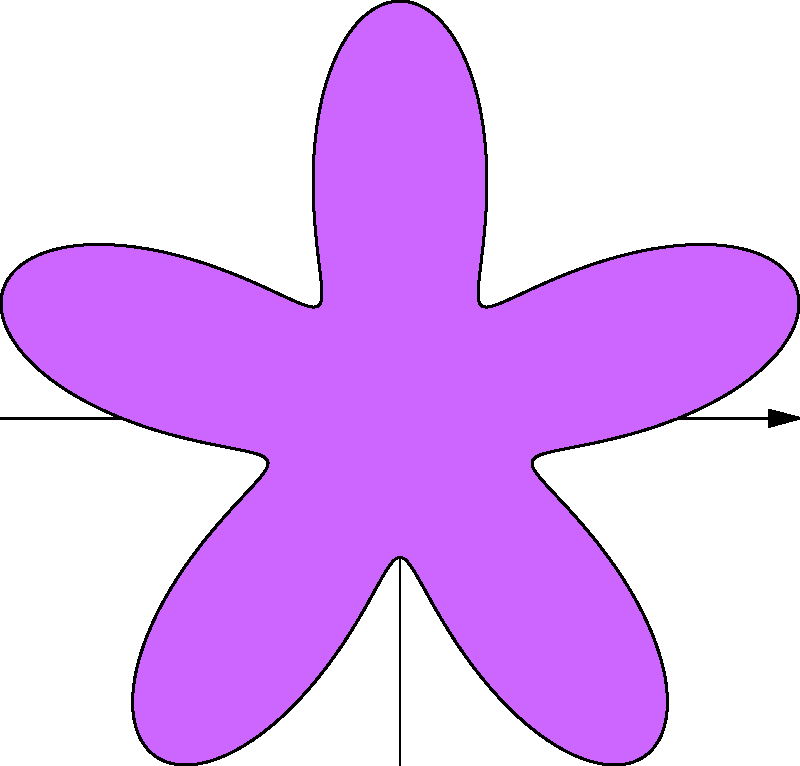As a quirky artist known for capturing Yagoton's essence in vibrant paintings, you're exploring polar equations to create a colorful flower with varying petal sizes. The flower is represented by the polar equation $r = 2 + \sin(5\theta)$. How many petals does this flower have, and what's the maximum radius of each petal? To determine the number of petals and their maximum radius, let's analyze the given polar equation:

1. Number of petals:
   The number of petals is determined by the coefficient of θ in the sine function.
   In this case, we have $\sin(5\theta)$, so there are 5 petals.

2. Maximum radius:
   The general form of the equation is $r = 2 + \sin(5\theta)$
   - The constant term (2) represents the base radius.
   - The sine function oscillates between -1 and 1.

   To find the maximum radius:
   $r_{max} = 2 + 1 = 3$

   This occurs when $\sin(5\theta) = 1$, which happens at the peak of each petal.

3. Verification:
   - We can see 5 distinct lobes in the graph, confirming 5 petals.
   - The petals extend beyond the circle with radius 2 (represented by the constant term),
     reaching a maximum at 3 units from the center.

Therefore, the flower has 5 petals, each with a maximum radius of 3 units.
Answer: 5 petals; maximum radius of 3 units 